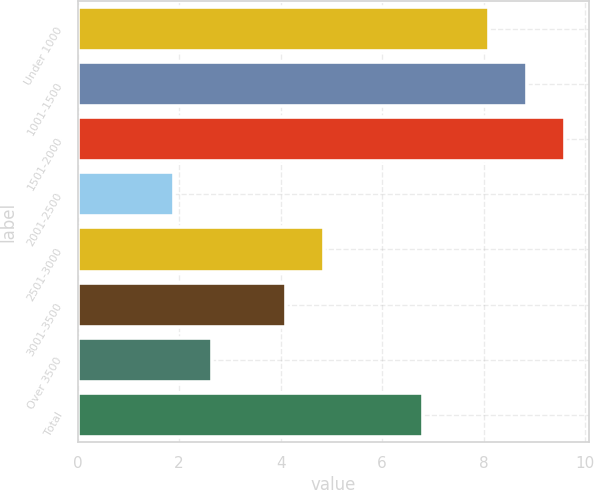Convert chart to OTSL. <chart><loc_0><loc_0><loc_500><loc_500><bar_chart><fcel>Under 1000<fcel>1001-1500<fcel>1501-2000<fcel>2001-2500<fcel>2501-3000<fcel>3001-3500<fcel>Over 3500<fcel>Total<nl><fcel>8.1<fcel>8.85<fcel>9.6<fcel>1.9<fcel>4.85<fcel>4.1<fcel>2.65<fcel>6.8<nl></chart> 